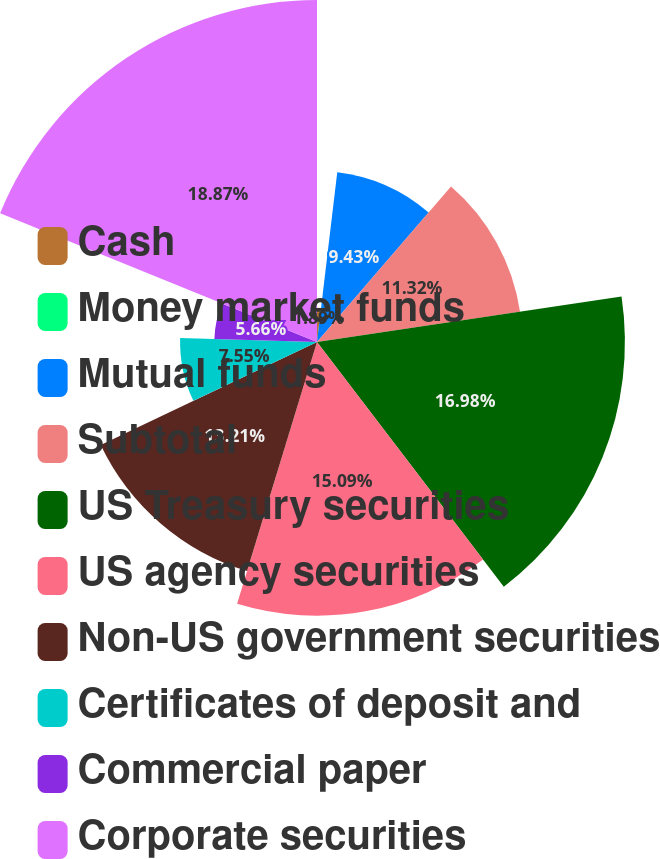Convert chart to OTSL. <chart><loc_0><loc_0><loc_500><loc_500><pie_chart><fcel>Cash<fcel>Money market funds<fcel>Mutual funds<fcel>Subtotal<fcel>US Treasury securities<fcel>US agency securities<fcel>Non-US government securities<fcel>Certificates of deposit and<fcel>Commercial paper<fcel>Corporate securities<nl><fcel>1.89%<fcel>0.0%<fcel>9.43%<fcel>11.32%<fcel>16.98%<fcel>15.09%<fcel>13.21%<fcel>7.55%<fcel>5.66%<fcel>18.86%<nl></chart> 